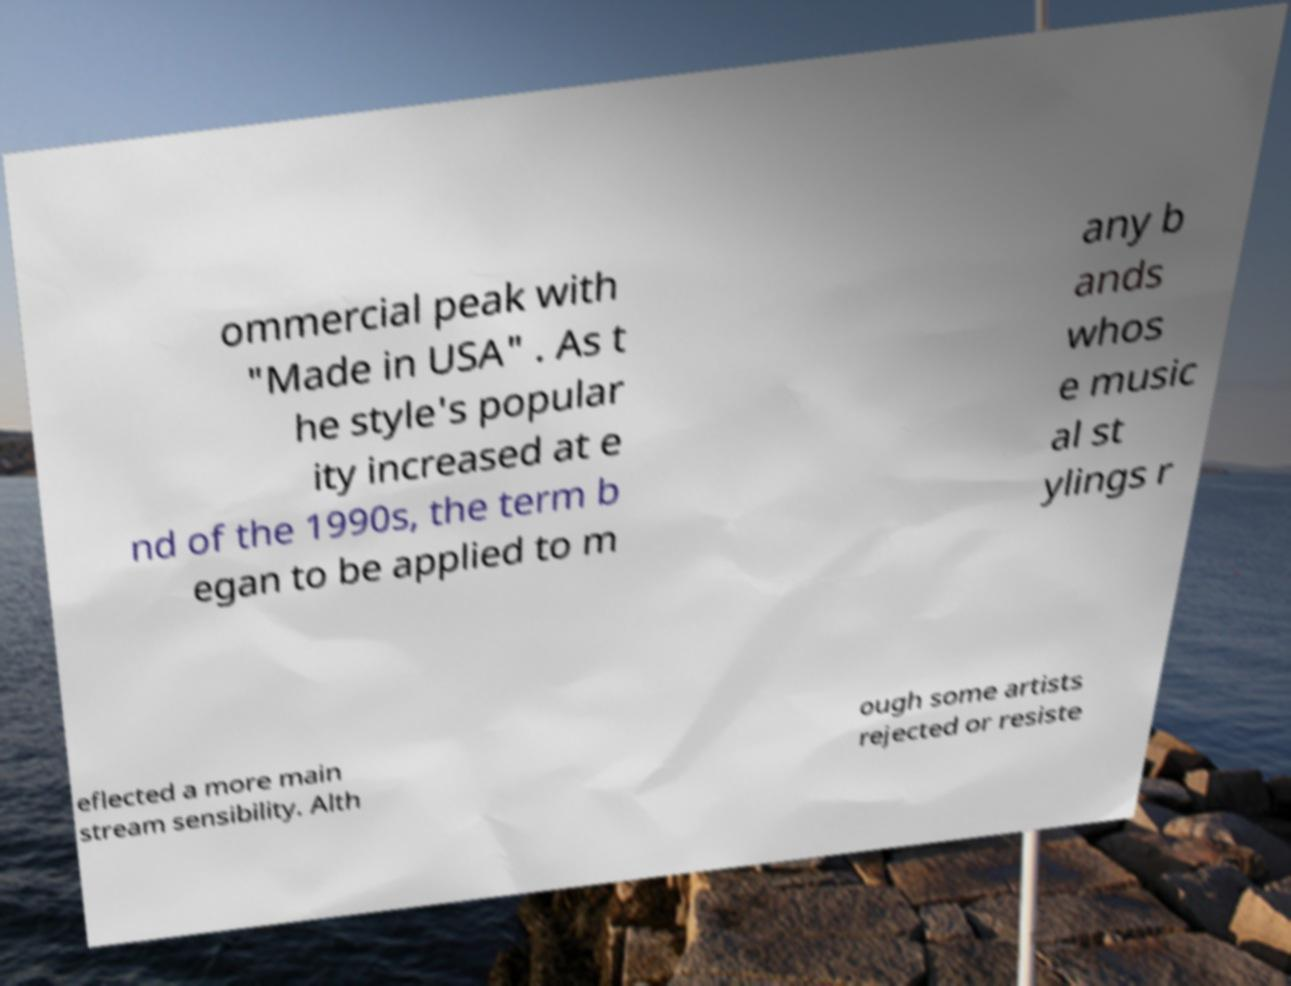What messages or text are displayed in this image? I need them in a readable, typed format. ommercial peak with "Made in USA" . As t he style's popular ity increased at e nd of the 1990s, the term b egan to be applied to m any b ands whos e music al st ylings r eflected a more main stream sensibility. Alth ough some artists rejected or resiste 